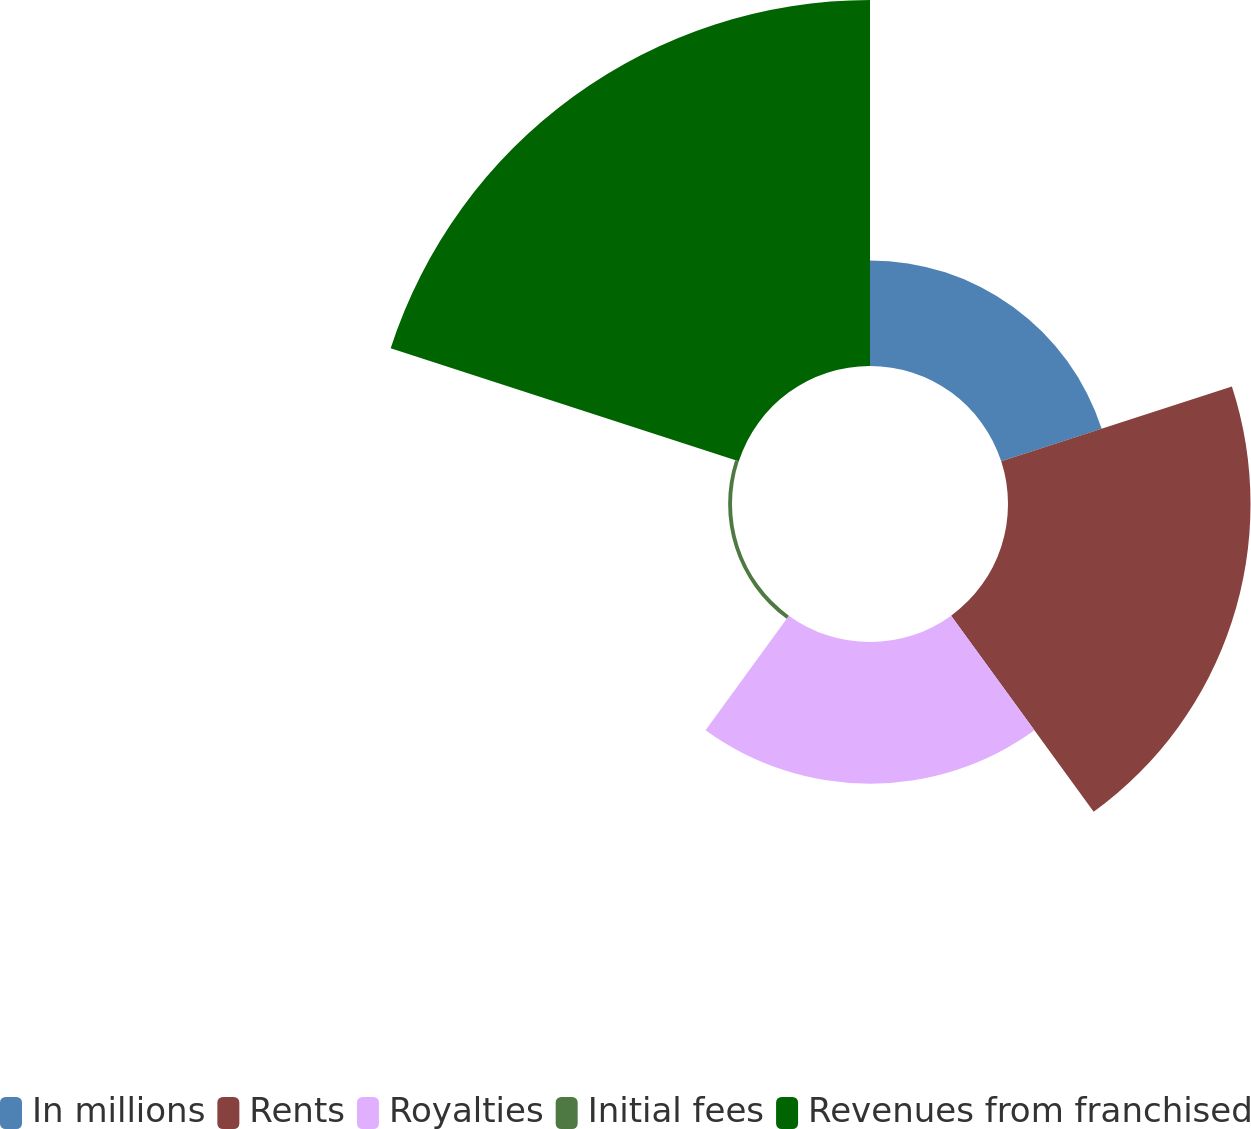<chart> <loc_0><loc_0><loc_500><loc_500><pie_chart><fcel>In millions<fcel>Rents<fcel>Royalties<fcel>Initial fees<fcel>Revenues from franchised<nl><fcel>12.28%<fcel>28.21%<fcel>16.49%<fcel>0.45%<fcel>42.57%<nl></chart> 